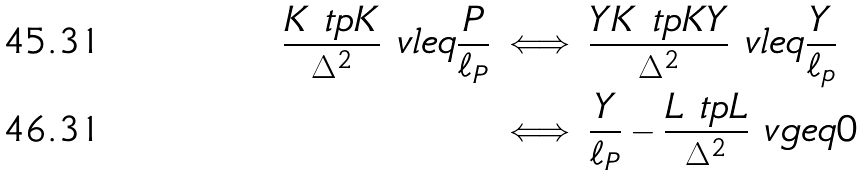Convert formula to latex. <formula><loc_0><loc_0><loc_500><loc_500>\frac { K \ t p K } { \Delta ^ { 2 } } \ v l e q \frac { P } { \ell _ { P } } & \iff \frac { Y K \ t p K Y } { \Delta ^ { 2 } } \ v l e q \frac { Y } { \ell _ { p } } \\ & \iff \frac { Y } { \ell _ { P } } - \frac { L \ t p L } { \Delta ^ { 2 } } \ v g e q 0</formula> 